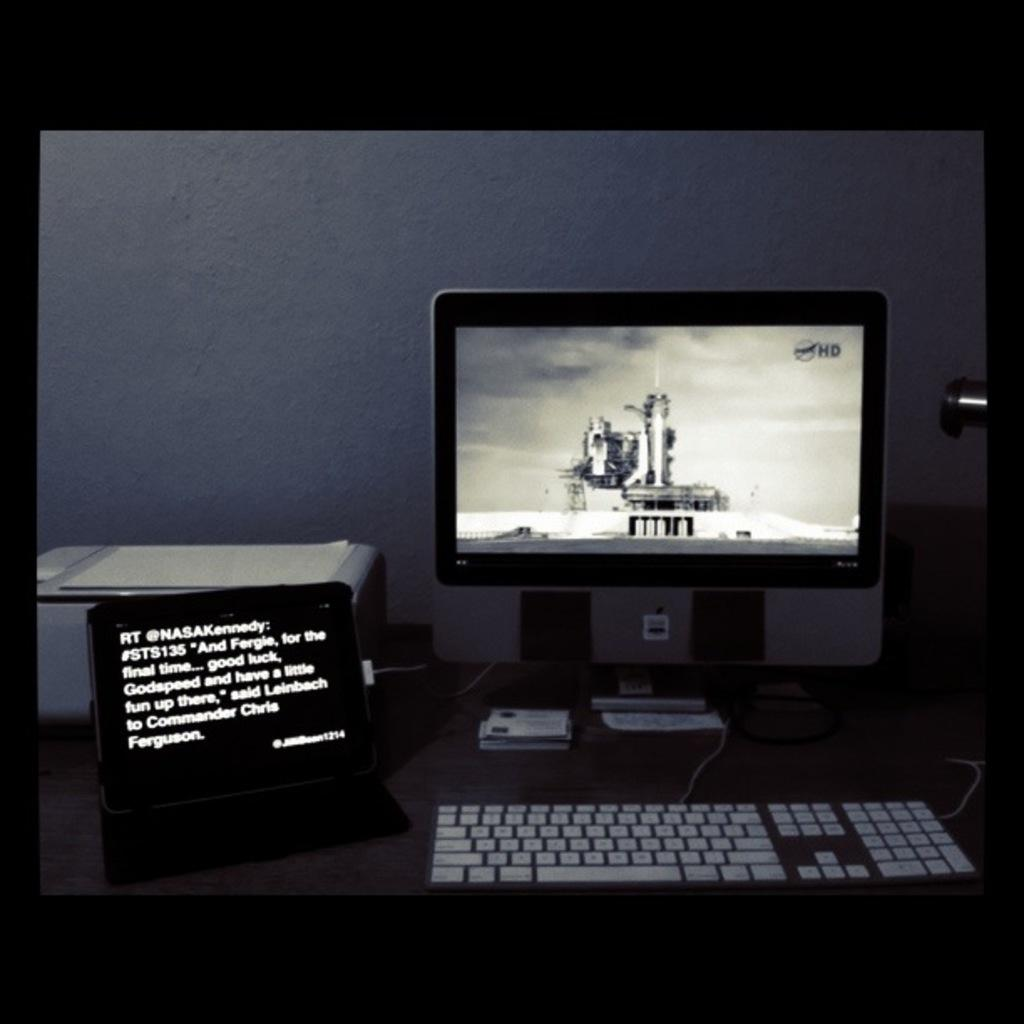<image>
Create a compact narrative representing the image presented. A sign that reads "RT @NASAkenndy" sits on a desk next to a computer 